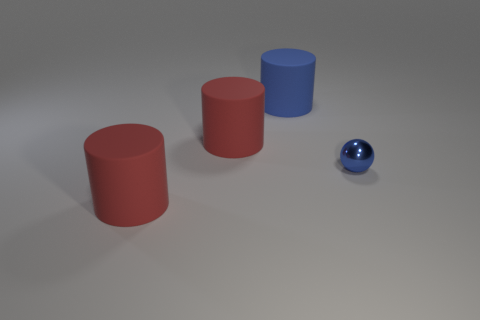Subtract 1 cylinders. How many cylinders are left? 2 Subtract all big blue cylinders. How many cylinders are left? 2 Add 2 red rubber objects. How many objects exist? 6 Subtract all cylinders. How many objects are left? 1 Subtract 0 green blocks. How many objects are left? 4 Subtract all red cylinders. Subtract all spheres. How many objects are left? 1 Add 2 matte cylinders. How many matte cylinders are left? 5 Add 3 blue balls. How many blue balls exist? 4 